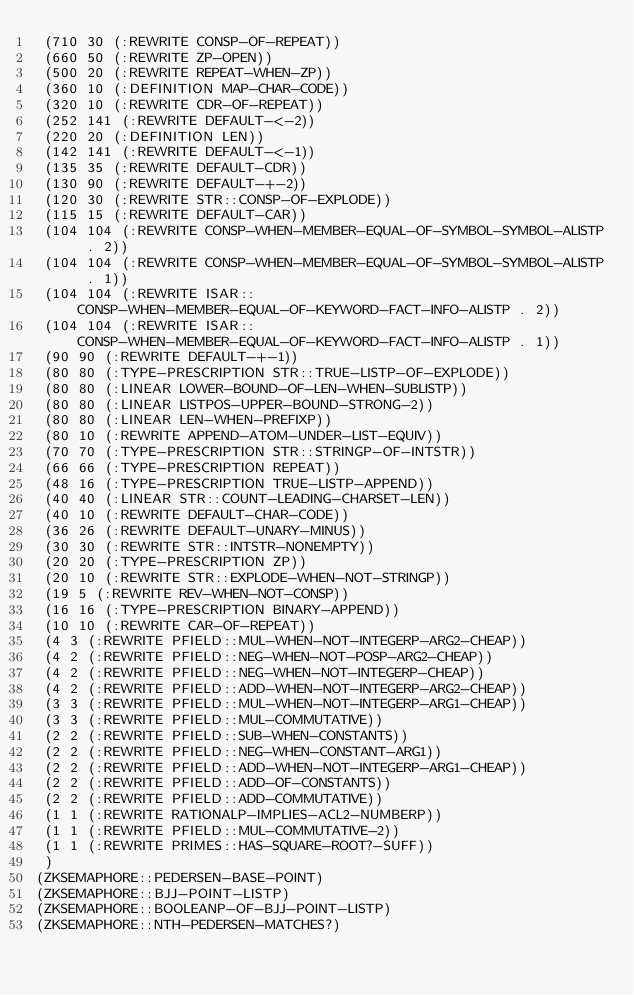Convert code to text. <code><loc_0><loc_0><loc_500><loc_500><_Lisp_> (710 30 (:REWRITE CONSP-OF-REPEAT))
 (660 50 (:REWRITE ZP-OPEN))
 (500 20 (:REWRITE REPEAT-WHEN-ZP))
 (360 10 (:DEFINITION MAP-CHAR-CODE))
 (320 10 (:REWRITE CDR-OF-REPEAT))
 (252 141 (:REWRITE DEFAULT-<-2))
 (220 20 (:DEFINITION LEN))
 (142 141 (:REWRITE DEFAULT-<-1))
 (135 35 (:REWRITE DEFAULT-CDR))
 (130 90 (:REWRITE DEFAULT-+-2))
 (120 30 (:REWRITE STR::CONSP-OF-EXPLODE))
 (115 15 (:REWRITE DEFAULT-CAR))
 (104 104 (:REWRITE CONSP-WHEN-MEMBER-EQUAL-OF-SYMBOL-SYMBOL-ALISTP . 2))
 (104 104 (:REWRITE CONSP-WHEN-MEMBER-EQUAL-OF-SYMBOL-SYMBOL-ALISTP . 1))
 (104 104 (:REWRITE ISAR::CONSP-WHEN-MEMBER-EQUAL-OF-KEYWORD-FACT-INFO-ALISTP . 2))
 (104 104 (:REWRITE ISAR::CONSP-WHEN-MEMBER-EQUAL-OF-KEYWORD-FACT-INFO-ALISTP . 1))
 (90 90 (:REWRITE DEFAULT-+-1))
 (80 80 (:TYPE-PRESCRIPTION STR::TRUE-LISTP-OF-EXPLODE))
 (80 80 (:LINEAR LOWER-BOUND-OF-LEN-WHEN-SUBLISTP))
 (80 80 (:LINEAR LISTPOS-UPPER-BOUND-STRONG-2))
 (80 80 (:LINEAR LEN-WHEN-PREFIXP))
 (80 10 (:REWRITE APPEND-ATOM-UNDER-LIST-EQUIV))
 (70 70 (:TYPE-PRESCRIPTION STR::STRINGP-OF-INTSTR))
 (66 66 (:TYPE-PRESCRIPTION REPEAT))
 (48 16 (:TYPE-PRESCRIPTION TRUE-LISTP-APPEND))
 (40 40 (:LINEAR STR::COUNT-LEADING-CHARSET-LEN))
 (40 10 (:REWRITE DEFAULT-CHAR-CODE))
 (36 26 (:REWRITE DEFAULT-UNARY-MINUS))
 (30 30 (:REWRITE STR::INTSTR-NONEMPTY))
 (20 20 (:TYPE-PRESCRIPTION ZP))
 (20 10 (:REWRITE STR::EXPLODE-WHEN-NOT-STRINGP))
 (19 5 (:REWRITE REV-WHEN-NOT-CONSP))
 (16 16 (:TYPE-PRESCRIPTION BINARY-APPEND))
 (10 10 (:REWRITE CAR-OF-REPEAT))
 (4 3 (:REWRITE PFIELD::MUL-WHEN-NOT-INTEGERP-ARG2-CHEAP))
 (4 2 (:REWRITE PFIELD::NEG-WHEN-NOT-POSP-ARG2-CHEAP))
 (4 2 (:REWRITE PFIELD::NEG-WHEN-NOT-INTEGERP-CHEAP))
 (4 2 (:REWRITE PFIELD::ADD-WHEN-NOT-INTEGERP-ARG2-CHEAP))
 (3 3 (:REWRITE PFIELD::MUL-WHEN-NOT-INTEGERP-ARG1-CHEAP))
 (3 3 (:REWRITE PFIELD::MUL-COMMUTATIVE))
 (2 2 (:REWRITE PFIELD::SUB-WHEN-CONSTANTS))
 (2 2 (:REWRITE PFIELD::NEG-WHEN-CONSTANT-ARG1))
 (2 2 (:REWRITE PFIELD::ADD-WHEN-NOT-INTEGERP-ARG1-CHEAP))
 (2 2 (:REWRITE PFIELD::ADD-OF-CONSTANTS))
 (2 2 (:REWRITE PFIELD::ADD-COMMUTATIVE))
 (1 1 (:REWRITE RATIONALP-IMPLIES-ACL2-NUMBERP))
 (1 1 (:REWRITE PFIELD::MUL-COMMUTATIVE-2))
 (1 1 (:REWRITE PRIMES::HAS-SQUARE-ROOT?-SUFF))
 )
(ZKSEMAPHORE::PEDERSEN-BASE-POINT)
(ZKSEMAPHORE::BJJ-POINT-LISTP)
(ZKSEMAPHORE::BOOLEANP-OF-BJJ-POINT-LISTP)
(ZKSEMAPHORE::NTH-PEDERSEN-MATCHES?)
</code> 